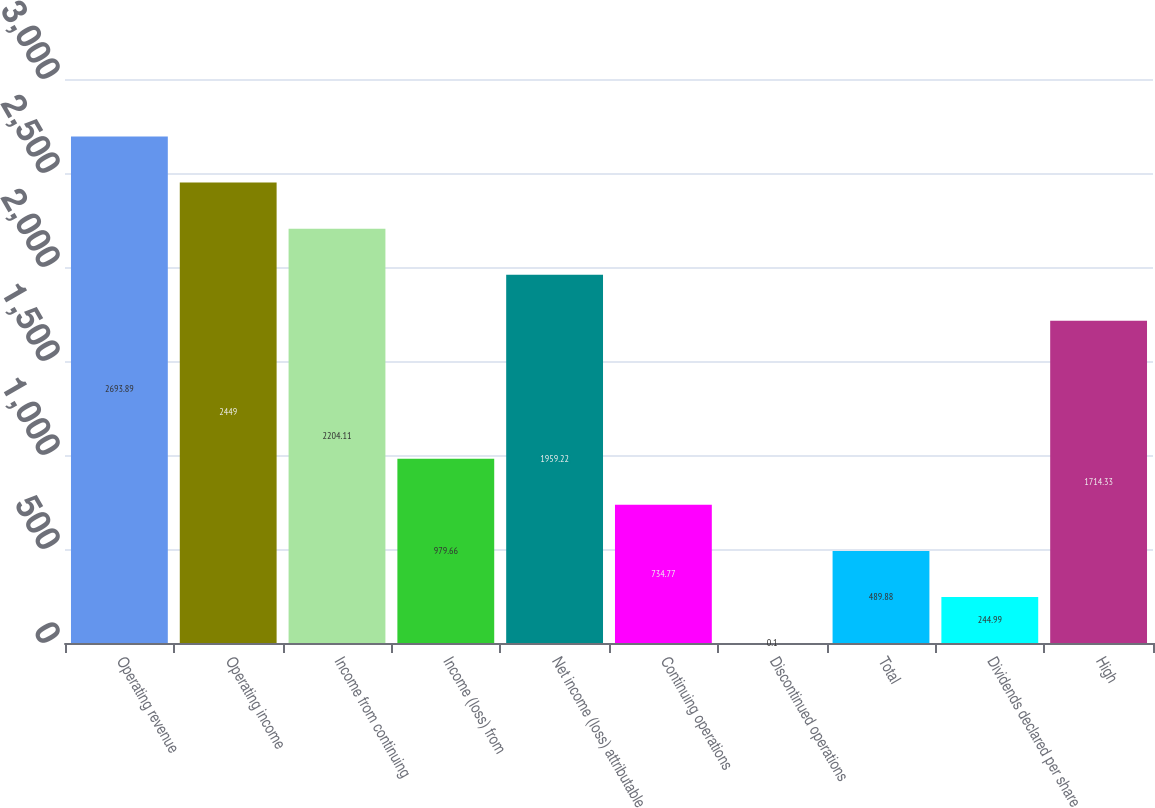Convert chart to OTSL. <chart><loc_0><loc_0><loc_500><loc_500><bar_chart><fcel>Operating revenue<fcel>Operating income<fcel>Income from continuing<fcel>Income (loss) from<fcel>Net income (loss) attributable<fcel>Continuing operations<fcel>Discontinued operations<fcel>Total<fcel>Dividends declared per share<fcel>High<nl><fcel>2693.89<fcel>2449<fcel>2204.11<fcel>979.66<fcel>1959.22<fcel>734.77<fcel>0.1<fcel>489.88<fcel>244.99<fcel>1714.33<nl></chart> 